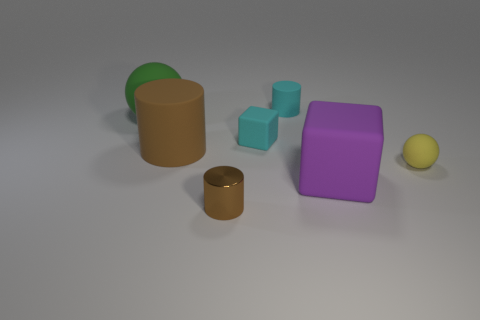Subtract all purple cylinders. Subtract all red spheres. How many cylinders are left? 3 Add 1 tiny cubes. How many objects exist? 8 Subtract all cylinders. How many objects are left? 4 Subtract all cyan objects. Subtract all small cyan cubes. How many objects are left? 4 Add 6 cylinders. How many cylinders are left? 9 Add 2 brown matte cylinders. How many brown matte cylinders exist? 3 Subtract 0 red blocks. How many objects are left? 7 